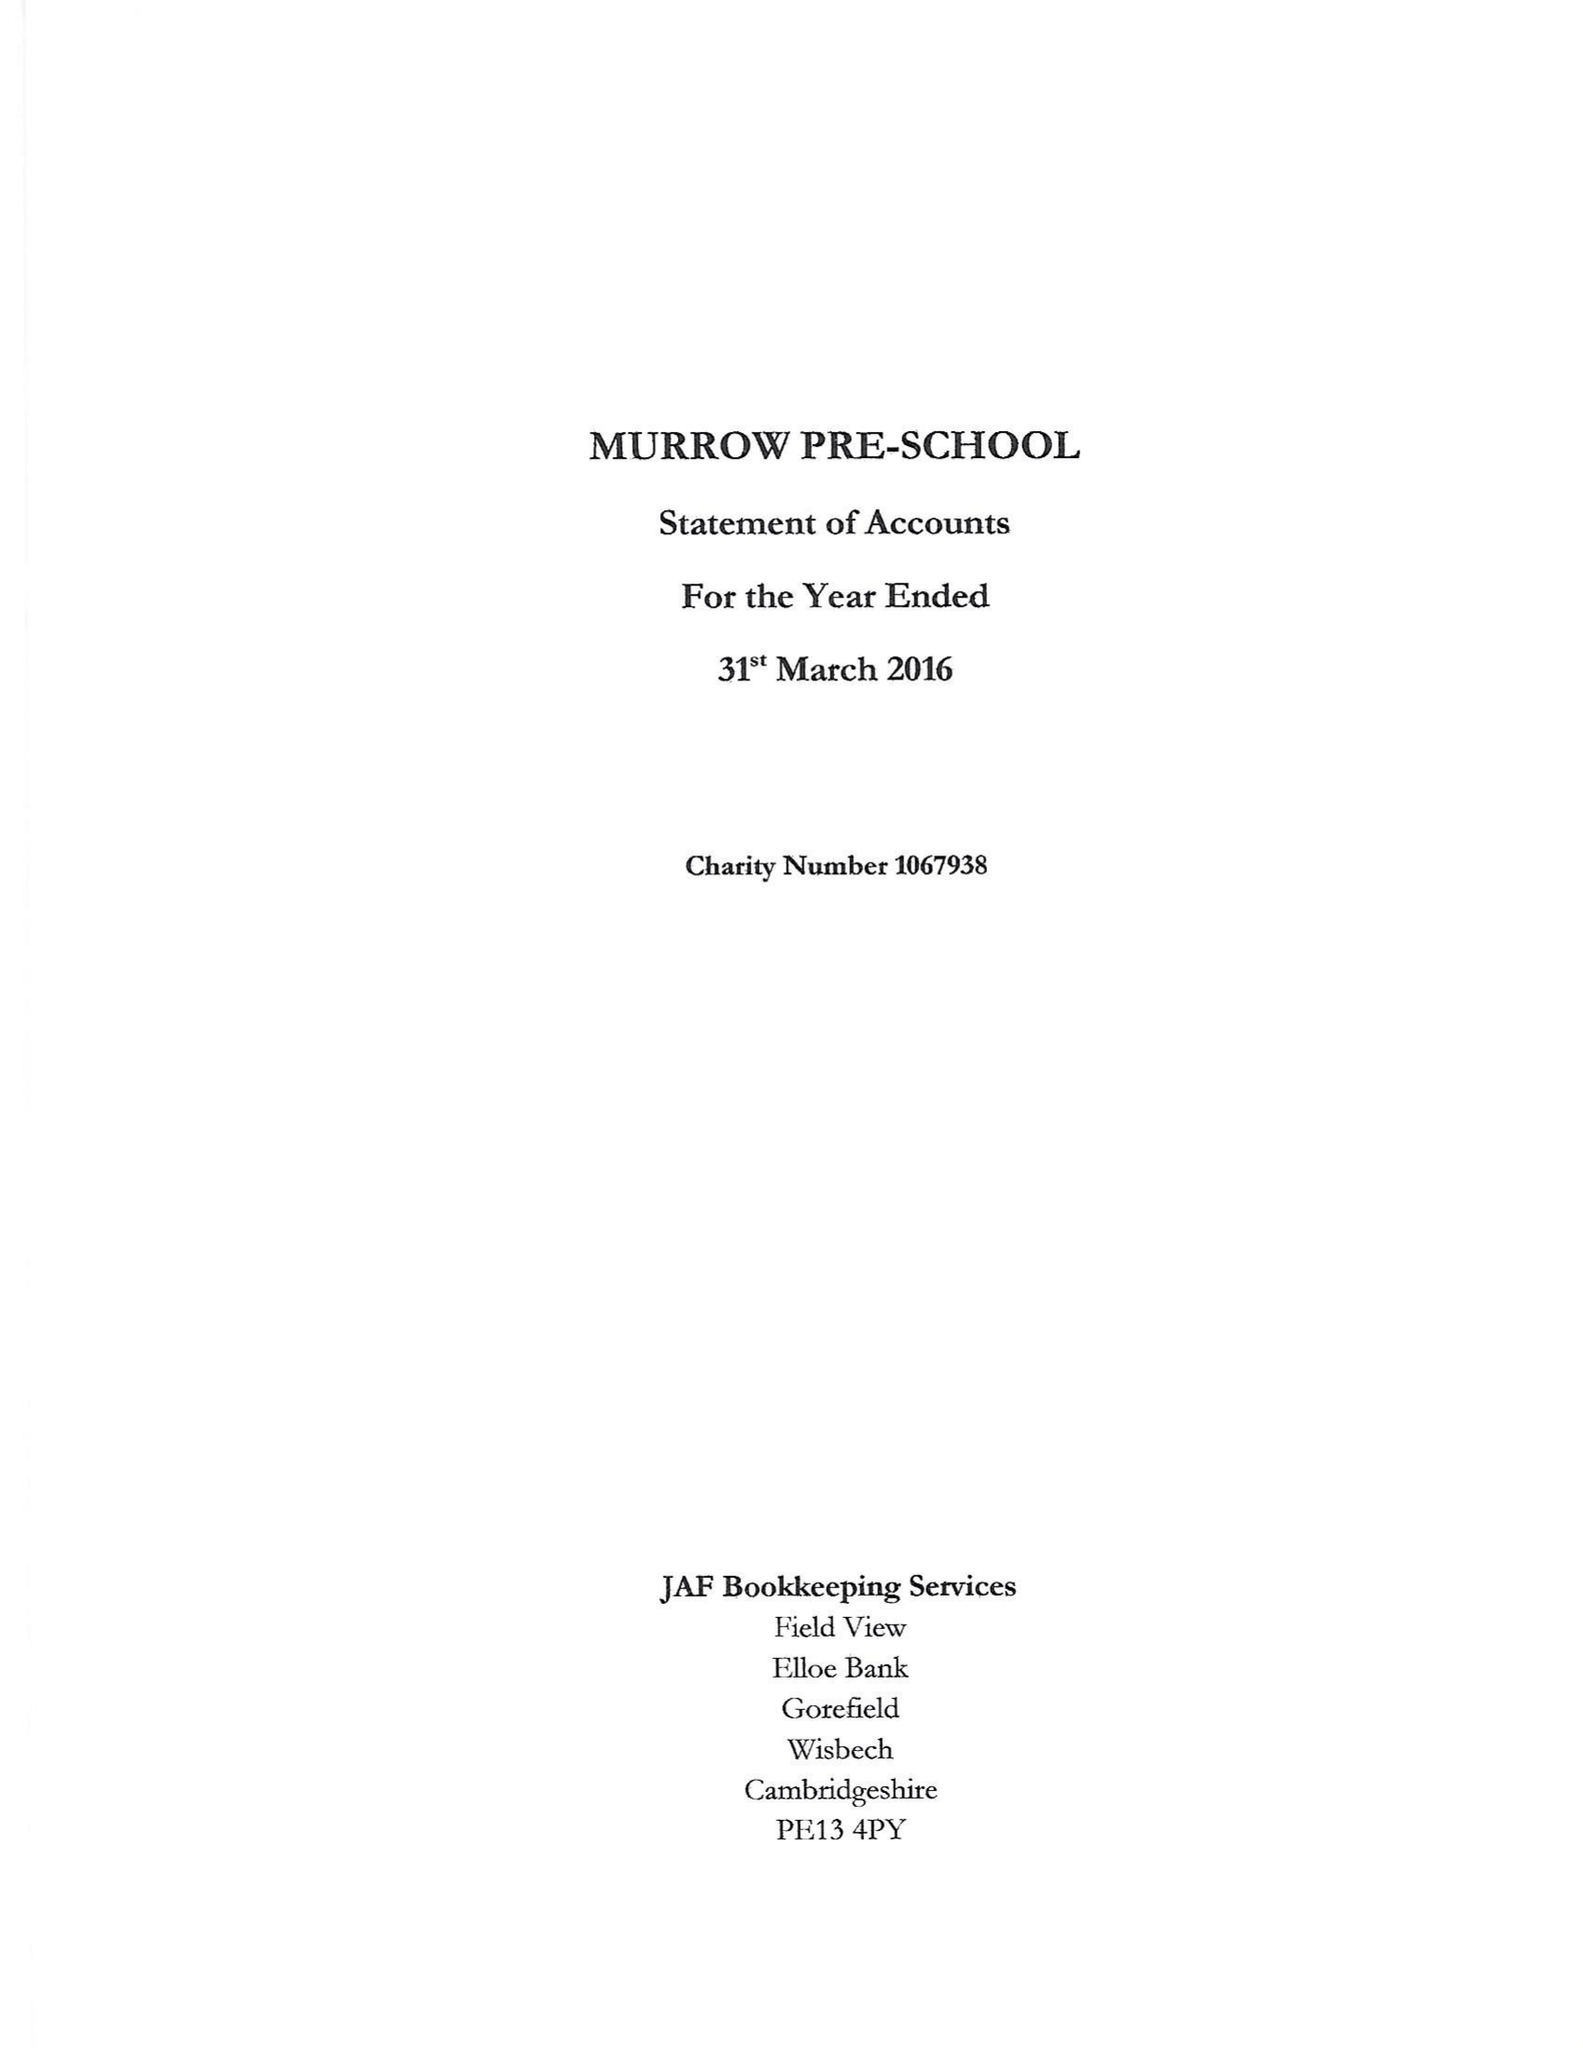What is the value for the charity_number?
Answer the question using a single word or phrase. 1067938 